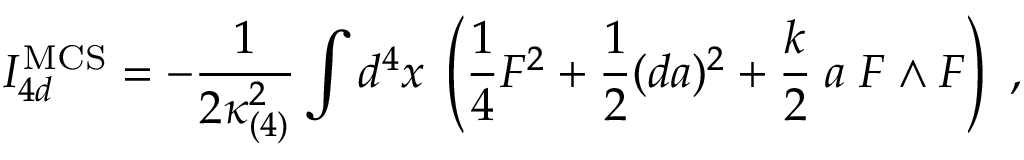<formula> <loc_0><loc_0><loc_500><loc_500>I _ { 4 d } ^ { M C S } = - { \frac { 1 } { 2 \kappa _ { ( 4 ) } ^ { 2 } } } \int d ^ { 4 } x \, \left ( { \frac { 1 } { 4 } } F ^ { 2 } + { \frac { 1 } { 2 } } ( d a ) ^ { 2 } + { \frac { k } { 2 } } \, a \, F \wedge F \right ) \ ,</formula> 